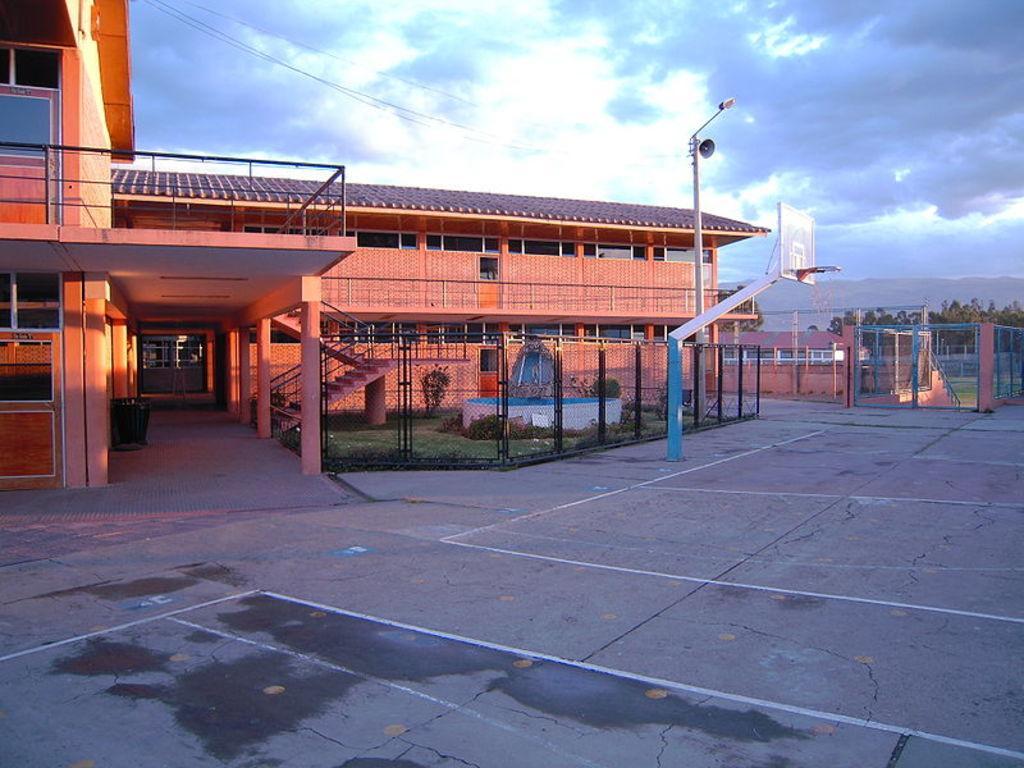Could you give a brief overview of what you see in this image? At the bottom of this image I can see the ground. In the middle of the image there is a building. On the right side there is a pole, a net fencing and also there are some trees. At the top of the image I can see the sky and clouds. 